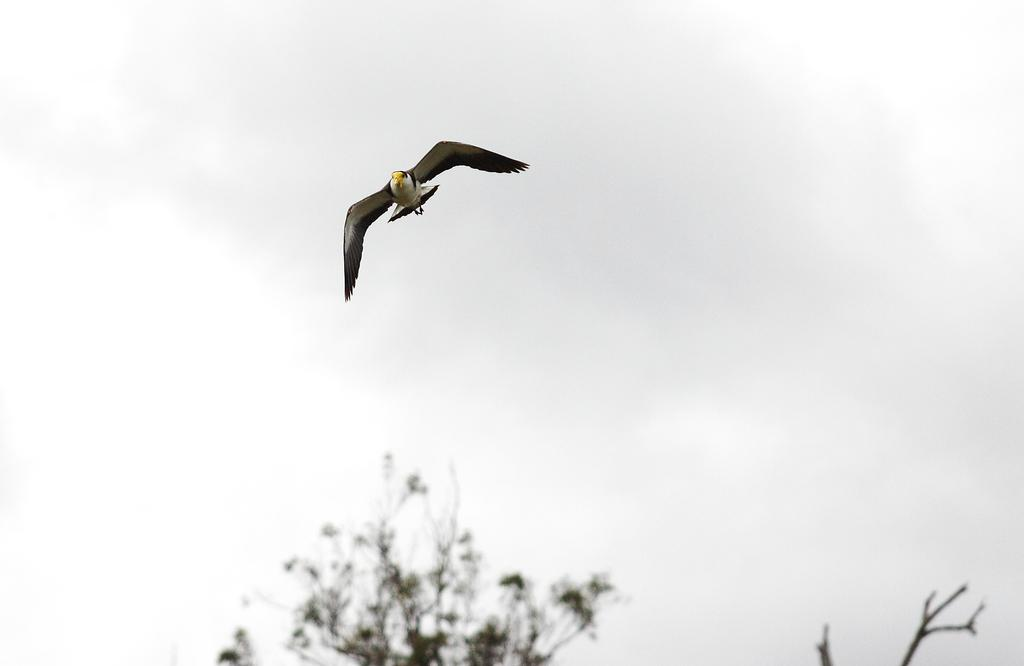What type of animal can be seen in the image? There is a bird in the image. What is the bird doing in the image? The bird is flying in the air. What can be seen in the background of the image? Trees and a cloudy sky are visible in the background of the image. How is the background of the image depicted? The background of the image is blurred. What type of gold title can be seen on the bird's head in the image? There is no gold title present on the bird's head in the image. Is there any evidence of a fight between the bird and another animal in the image? There is no fight or any other animals present in the image; it only features a bird flying in the air. 